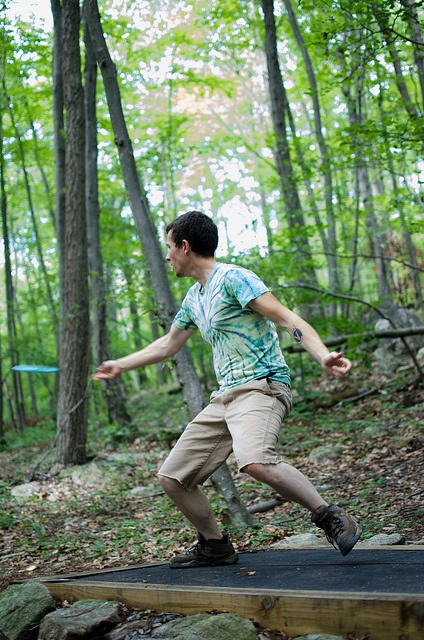Describe the objects in this image and their specific colors. I can see people in lavender, darkgray, gray, lightgray, and black tones and frisbee in lavender, lightblue, turquoise, and teal tones in this image. 